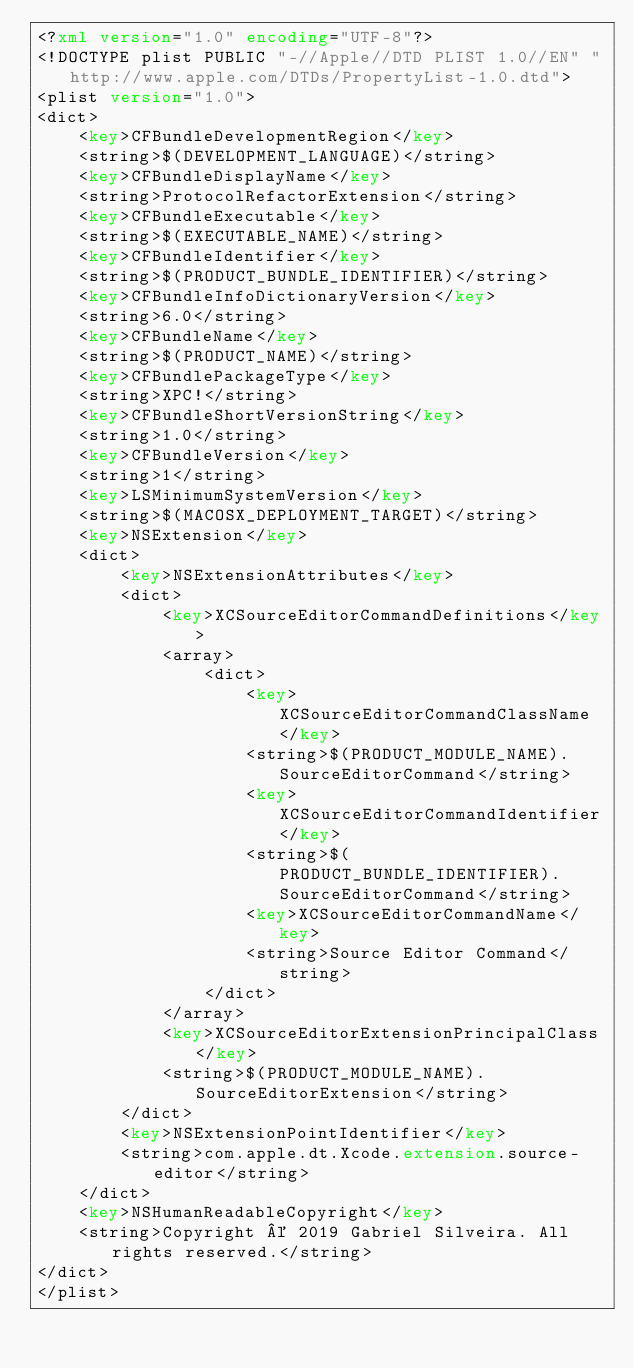Convert code to text. <code><loc_0><loc_0><loc_500><loc_500><_XML_><?xml version="1.0" encoding="UTF-8"?>
<!DOCTYPE plist PUBLIC "-//Apple//DTD PLIST 1.0//EN" "http://www.apple.com/DTDs/PropertyList-1.0.dtd">
<plist version="1.0">
<dict>
	<key>CFBundleDevelopmentRegion</key>
	<string>$(DEVELOPMENT_LANGUAGE)</string>
	<key>CFBundleDisplayName</key>
	<string>ProtocolRefactorExtension</string>
	<key>CFBundleExecutable</key>
	<string>$(EXECUTABLE_NAME)</string>
	<key>CFBundleIdentifier</key>
	<string>$(PRODUCT_BUNDLE_IDENTIFIER)</string>
	<key>CFBundleInfoDictionaryVersion</key>
	<string>6.0</string>
	<key>CFBundleName</key>
	<string>$(PRODUCT_NAME)</string>
	<key>CFBundlePackageType</key>
	<string>XPC!</string>
	<key>CFBundleShortVersionString</key>
	<string>1.0</string>
	<key>CFBundleVersion</key>
	<string>1</string>
	<key>LSMinimumSystemVersion</key>
	<string>$(MACOSX_DEPLOYMENT_TARGET)</string>
	<key>NSExtension</key>
	<dict>
		<key>NSExtensionAttributes</key>
		<dict>
			<key>XCSourceEditorCommandDefinitions</key>
			<array>
				<dict>
					<key>XCSourceEditorCommandClassName</key>
					<string>$(PRODUCT_MODULE_NAME).SourceEditorCommand</string>
					<key>XCSourceEditorCommandIdentifier</key>
					<string>$(PRODUCT_BUNDLE_IDENTIFIER).SourceEditorCommand</string>
					<key>XCSourceEditorCommandName</key>
					<string>Source Editor Command</string>
				</dict>
			</array>
			<key>XCSourceEditorExtensionPrincipalClass</key>
			<string>$(PRODUCT_MODULE_NAME).SourceEditorExtension</string>
		</dict>
		<key>NSExtensionPointIdentifier</key>
		<string>com.apple.dt.Xcode.extension.source-editor</string>
	</dict>
	<key>NSHumanReadableCopyright</key>
	<string>Copyright © 2019 Gabriel Silveira. All rights reserved.</string>
</dict>
</plist>
</code> 